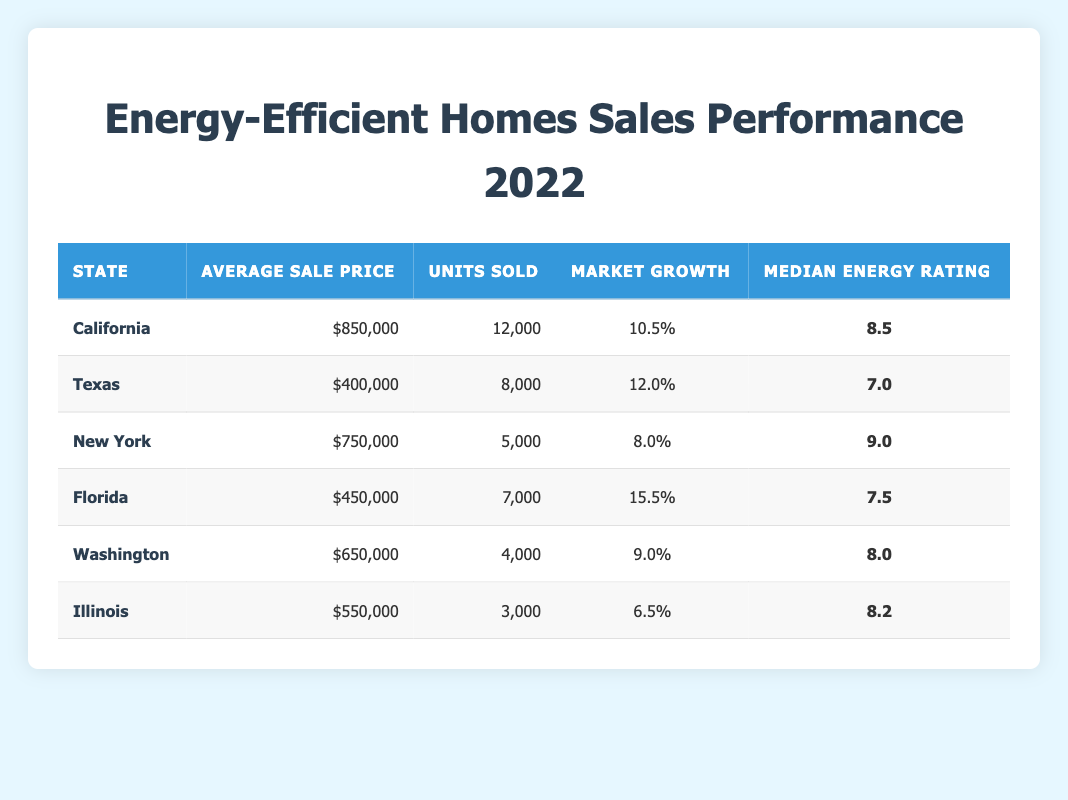What is the average sale price of energy-efficient homes in California? The table shows the average sale price for California as $850,000, directly found in the respective row of the table.
Answer: $850,000 Which state had the highest number of units sold for energy-efficient homes? California has the highest units sold, totaling 12,000 units, which is greater than any other state listed in the table.
Answer: California What is the total market growth percentage for Florida and Texas combined? Florida's market growth percentage is 15.5, and Texas's is 12.0. Adding these gives 15.5 + 12.0 = 27.5.
Answer: 27.5 Is the median energy rating in New York higher than that in Illinois? The median energy rating for New York is 9.0 and for Illinois it's 8.2. Since 9.0 > 8.2, the statement is true.
Answer: Yes What is the difference between the average sale price of energy-efficient homes in Florida and Illinois? Florida's average sale price is $450,000 and Illinois's is $550,000. The difference is $550,000 - $450,000 = $100,000.
Answer: $100,000 Which state has the lowest market growth percentage for energy-efficient homes? By reviewing the table, Illinois has the lowest market growth percentage at 6.5, lower than every other state listed.
Answer: Illinois If we average the median energy ratings of all states, what is the result? Adding the median ratings (8.5 + 7.0 + 9.0 + 7.5 + 8.0 + 8.2 = 48.2) gives 48.2, and dividing by 6 (the number of states) gives 48.2 / 6 = 8.03.
Answer: 8.03 Does Texas have a higher average sale price than New York? Texas has an average sale price of $400,000, while New York has $750,000. Since $400,000 is not higher than $750,000, the statement is false.
Answer: No Which two states have the most similar average sale prices? Comparing the average sale prices, Texas ($400,000) and Florida ($450,000) are closest, with a difference of $50,000, making them the two most similar.
Answer: Texas and Florida 